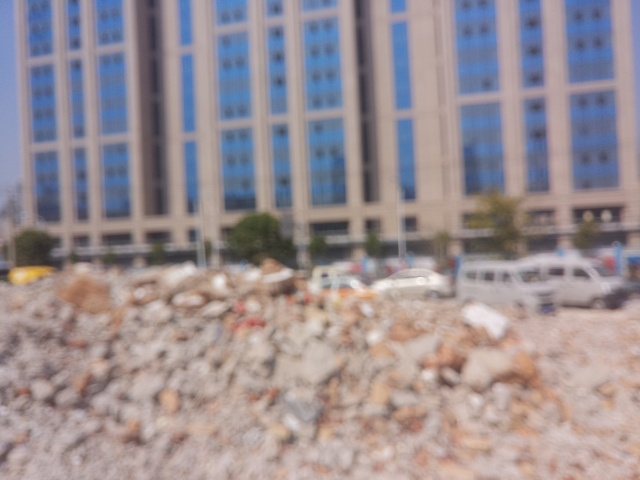Are there any quality issues with this image? Yes, the primary quality issue with this image is that it is out of focus, resulting in a blurry appearance that obscures the details of the subject matter, which appears to be a construction or demolition site in front of a multistory building. 